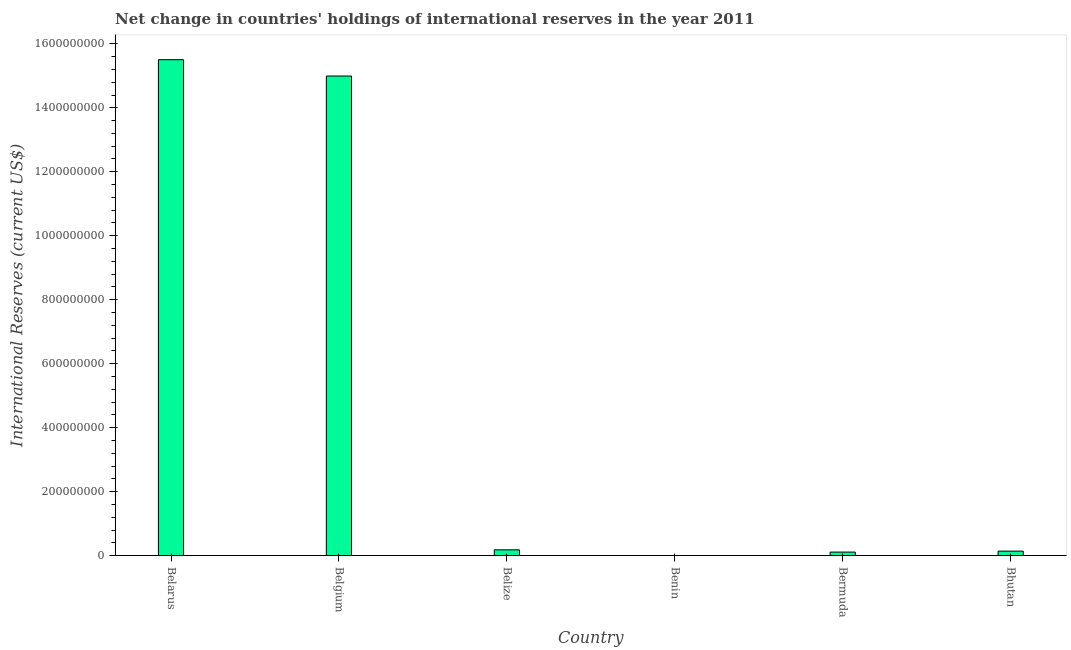Does the graph contain grids?
Give a very brief answer. No. What is the title of the graph?
Your response must be concise. Net change in countries' holdings of international reserves in the year 2011. What is the label or title of the X-axis?
Your answer should be very brief. Country. What is the label or title of the Y-axis?
Your response must be concise. International Reserves (current US$). What is the reserves and related items in Belgium?
Make the answer very short. 1.50e+09. Across all countries, what is the maximum reserves and related items?
Your answer should be very brief. 1.55e+09. In which country was the reserves and related items maximum?
Offer a very short reply. Belarus. What is the sum of the reserves and related items?
Your response must be concise. 3.09e+09. What is the difference between the reserves and related items in Belgium and Bermuda?
Your answer should be very brief. 1.49e+09. What is the average reserves and related items per country?
Provide a succinct answer. 5.16e+08. What is the median reserves and related items?
Make the answer very short. 1.62e+07. What is the ratio of the reserves and related items in Belgium to that in Bhutan?
Offer a terse response. 106.2. Is the difference between the reserves and related items in Belgium and Bhutan greater than the difference between any two countries?
Provide a succinct answer. No. What is the difference between the highest and the second highest reserves and related items?
Keep it short and to the point. 5.11e+07. What is the difference between the highest and the lowest reserves and related items?
Your answer should be compact. 1.55e+09. How many bars are there?
Your answer should be compact. 5. Are all the bars in the graph horizontal?
Keep it short and to the point. No. How many countries are there in the graph?
Your answer should be very brief. 6. Are the values on the major ticks of Y-axis written in scientific E-notation?
Provide a succinct answer. No. What is the International Reserves (current US$) in Belarus?
Your response must be concise. 1.55e+09. What is the International Reserves (current US$) in Belgium?
Offer a very short reply. 1.50e+09. What is the International Reserves (current US$) of Belize?
Provide a succinct answer. 1.82e+07. What is the International Reserves (current US$) in Benin?
Make the answer very short. 0. What is the International Reserves (current US$) of Bermuda?
Your answer should be compact. 1.12e+07. What is the International Reserves (current US$) of Bhutan?
Give a very brief answer. 1.41e+07. What is the difference between the International Reserves (current US$) in Belarus and Belgium?
Make the answer very short. 5.11e+07. What is the difference between the International Reserves (current US$) in Belarus and Belize?
Your answer should be compact. 1.53e+09. What is the difference between the International Reserves (current US$) in Belarus and Bermuda?
Ensure brevity in your answer.  1.54e+09. What is the difference between the International Reserves (current US$) in Belarus and Bhutan?
Provide a succinct answer. 1.54e+09. What is the difference between the International Reserves (current US$) in Belgium and Belize?
Your answer should be very brief. 1.48e+09. What is the difference between the International Reserves (current US$) in Belgium and Bermuda?
Keep it short and to the point. 1.49e+09. What is the difference between the International Reserves (current US$) in Belgium and Bhutan?
Your answer should be very brief. 1.49e+09. What is the difference between the International Reserves (current US$) in Belize and Bermuda?
Give a very brief answer. 7.06e+06. What is the difference between the International Reserves (current US$) in Belize and Bhutan?
Provide a short and direct response. 4.09e+06. What is the difference between the International Reserves (current US$) in Bermuda and Bhutan?
Provide a short and direct response. -2.97e+06. What is the ratio of the International Reserves (current US$) in Belarus to that in Belgium?
Provide a succinct answer. 1.03. What is the ratio of the International Reserves (current US$) in Belarus to that in Belize?
Your answer should be compact. 85.13. What is the ratio of the International Reserves (current US$) in Belarus to that in Bermuda?
Provide a succinct answer. 139.04. What is the ratio of the International Reserves (current US$) in Belarus to that in Bhutan?
Make the answer very short. 109.82. What is the ratio of the International Reserves (current US$) in Belgium to that in Belize?
Keep it short and to the point. 82.33. What is the ratio of the International Reserves (current US$) in Belgium to that in Bermuda?
Make the answer very short. 134.45. What is the ratio of the International Reserves (current US$) in Belgium to that in Bhutan?
Make the answer very short. 106.2. What is the ratio of the International Reserves (current US$) in Belize to that in Bermuda?
Offer a terse response. 1.63. What is the ratio of the International Reserves (current US$) in Belize to that in Bhutan?
Your response must be concise. 1.29. What is the ratio of the International Reserves (current US$) in Bermuda to that in Bhutan?
Keep it short and to the point. 0.79. 